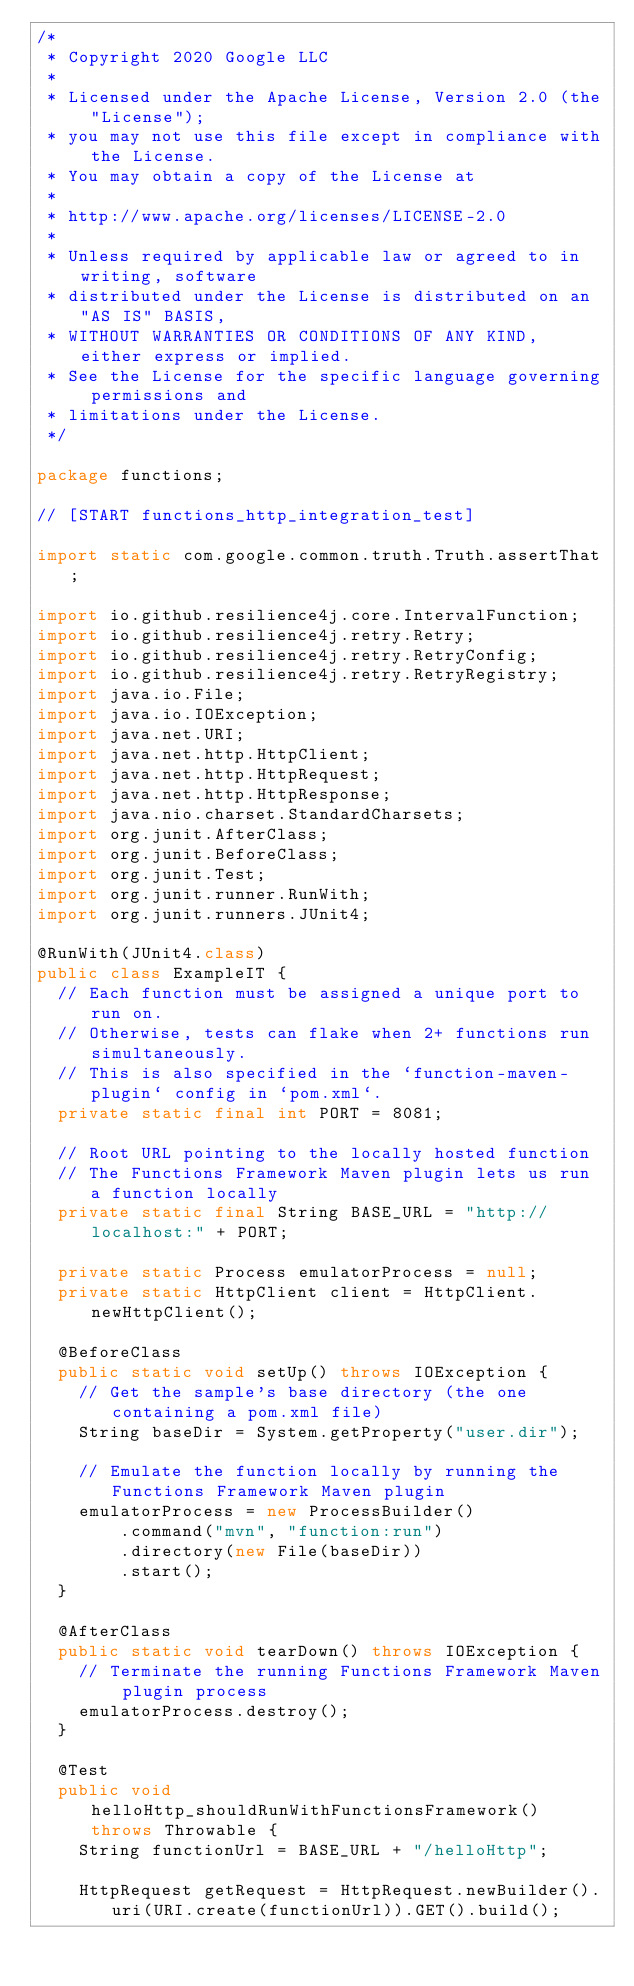<code> <loc_0><loc_0><loc_500><loc_500><_Java_>/*
 * Copyright 2020 Google LLC
 *
 * Licensed under the Apache License, Version 2.0 (the "License");
 * you may not use this file except in compliance with the License.
 * You may obtain a copy of the License at
 *
 * http://www.apache.org/licenses/LICENSE-2.0
 *
 * Unless required by applicable law or agreed to in writing, software
 * distributed under the License is distributed on an "AS IS" BASIS,
 * WITHOUT WARRANTIES OR CONDITIONS OF ANY KIND, either express or implied.
 * See the License for the specific language governing permissions and
 * limitations under the License.
 */

package functions;

// [START functions_http_integration_test]

import static com.google.common.truth.Truth.assertThat;

import io.github.resilience4j.core.IntervalFunction;
import io.github.resilience4j.retry.Retry;
import io.github.resilience4j.retry.RetryConfig;
import io.github.resilience4j.retry.RetryRegistry;
import java.io.File;
import java.io.IOException;
import java.net.URI;
import java.net.http.HttpClient;
import java.net.http.HttpRequest;
import java.net.http.HttpResponse;
import java.nio.charset.StandardCharsets;
import org.junit.AfterClass;
import org.junit.BeforeClass;
import org.junit.Test;
import org.junit.runner.RunWith;
import org.junit.runners.JUnit4;

@RunWith(JUnit4.class)
public class ExampleIT {
  // Each function must be assigned a unique port to run on.
  // Otherwise, tests can flake when 2+ functions run simultaneously.
  // This is also specified in the `function-maven-plugin` config in `pom.xml`.
  private static final int PORT = 8081;

  // Root URL pointing to the locally hosted function
  // The Functions Framework Maven plugin lets us run a function locally
  private static final String BASE_URL = "http://localhost:" + PORT;

  private static Process emulatorProcess = null;
  private static HttpClient client = HttpClient.newHttpClient();

  @BeforeClass
  public static void setUp() throws IOException {
    // Get the sample's base directory (the one containing a pom.xml file)
    String baseDir = System.getProperty("user.dir");

    // Emulate the function locally by running the Functions Framework Maven plugin
    emulatorProcess = new ProcessBuilder()
        .command("mvn", "function:run")
        .directory(new File(baseDir))
        .start();
  }

  @AfterClass
  public static void tearDown() throws IOException {
    // Terminate the running Functions Framework Maven plugin process
    emulatorProcess.destroy();
  }

  @Test
  public void helloHttp_shouldRunWithFunctionsFramework() throws Throwable {
    String functionUrl = BASE_URL + "/helloHttp";

    HttpRequest getRequest = HttpRequest.newBuilder().uri(URI.create(functionUrl)).GET().build();
</code> 